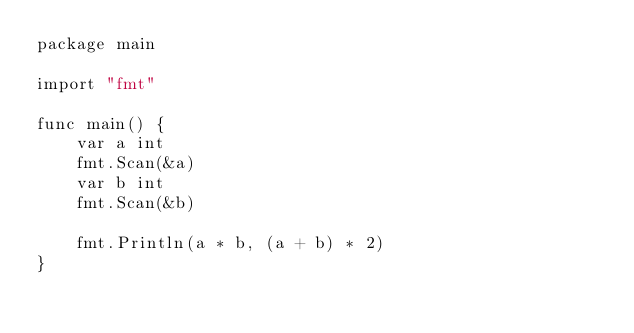<code> <loc_0><loc_0><loc_500><loc_500><_Go_>package main

import "fmt"

func main() {
    var a int
    fmt.Scan(&a)
    var b int
    fmt.Scan(&b)

    fmt.Println(a * b, (a + b) * 2)
}
</code> 